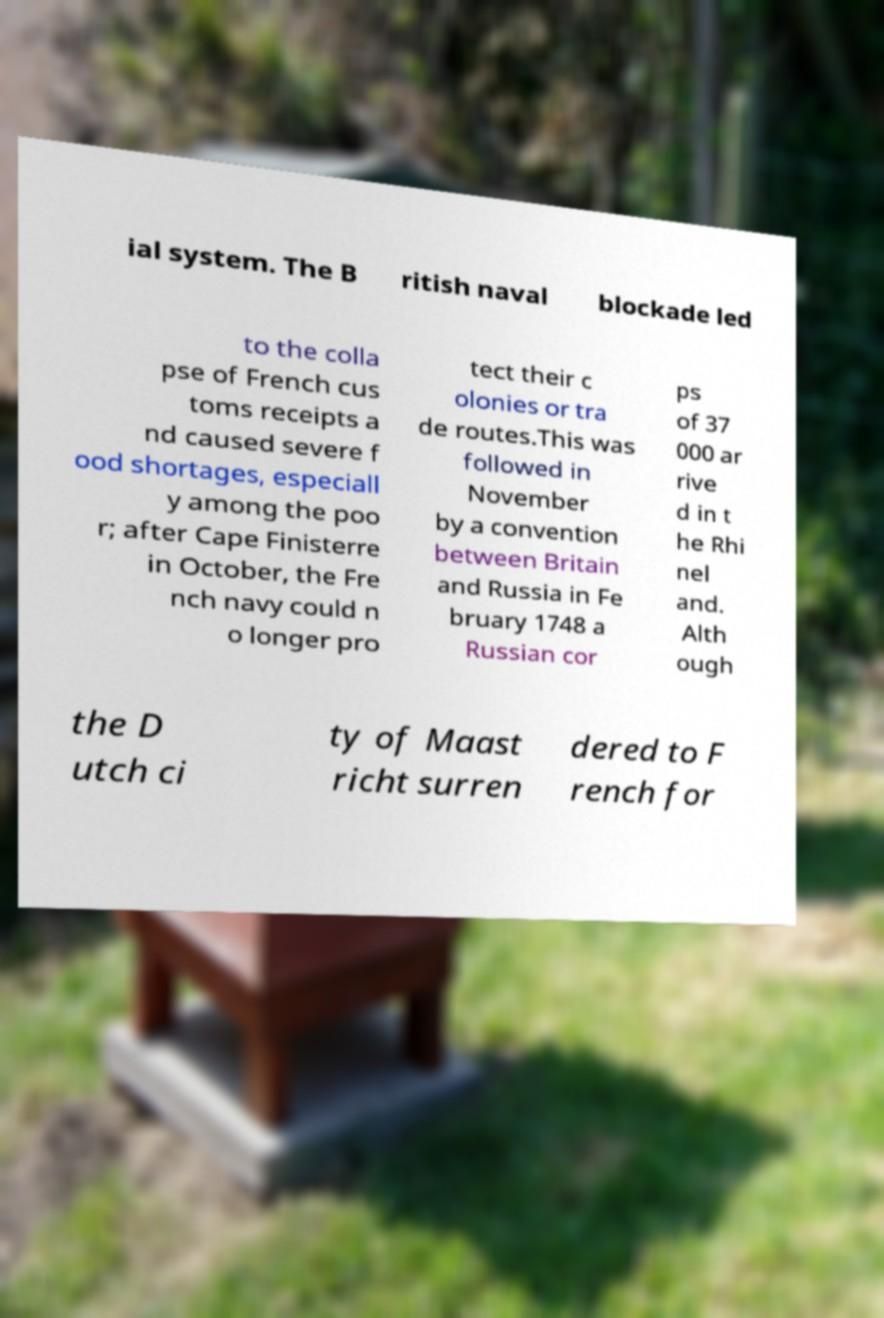Can you read and provide the text displayed in the image?This photo seems to have some interesting text. Can you extract and type it out for me? ial system. The B ritish naval blockade led to the colla pse of French cus toms receipts a nd caused severe f ood shortages, especiall y among the poo r; after Cape Finisterre in October, the Fre nch navy could n o longer pro tect their c olonies or tra de routes.This was followed in November by a convention between Britain and Russia in Fe bruary 1748 a Russian cor ps of 37 000 ar rive d in t he Rhi nel and. Alth ough the D utch ci ty of Maast richt surren dered to F rench for 